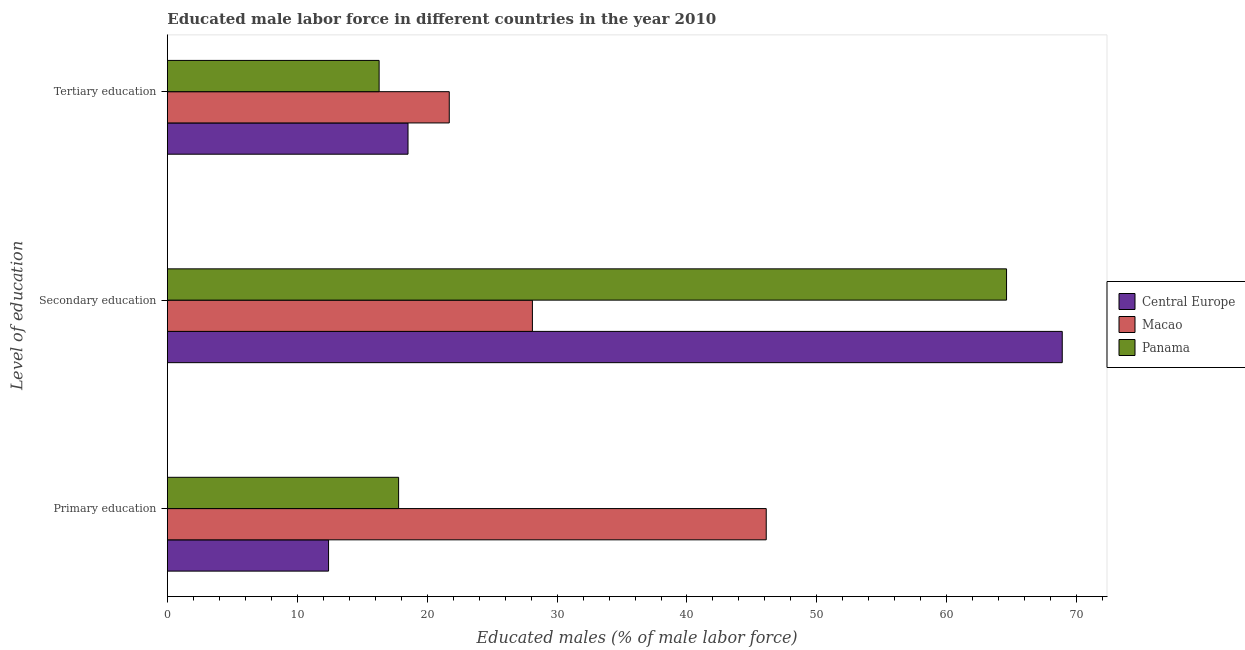Are the number of bars per tick equal to the number of legend labels?
Provide a short and direct response. Yes. What is the label of the 2nd group of bars from the top?
Make the answer very short. Secondary education. What is the percentage of male labor force who received primary education in Central Europe?
Your response must be concise. 12.41. Across all countries, what is the maximum percentage of male labor force who received tertiary education?
Keep it short and to the point. 21.7. Across all countries, what is the minimum percentage of male labor force who received secondary education?
Offer a very short reply. 28.1. In which country was the percentage of male labor force who received secondary education maximum?
Give a very brief answer. Central Europe. In which country was the percentage of male labor force who received secondary education minimum?
Your answer should be very brief. Macao. What is the total percentage of male labor force who received secondary education in the graph?
Give a very brief answer. 161.59. What is the difference between the percentage of male labor force who received primary education in Panama and that in Macao?
Provide a succinct answer. -28.3. What is the difference between the percentage of male labor force who received secondary education in Macao and the percentage of male labor force who received tertiary education in Panama?
Keep it short and to the point. 11.8. What is the average percentage of male labor force who received secondary education per country?
Provide a short and direct response. 53.86. What is the difference between the percentage of male labor force who received primary education and percentage of male labor force who received tertiary education in Macao?
Give a very brief answer. 24.4. What is the ratio of the percentage of male labor force who received secondary education in Central Europe to that in Macao?
Keep it short and to the point. 2.45. What is the difference between the highest and the second highest percentage of male labor force who received primary education?
Your answer should be compact. 28.3. What is the difference between the highest and the lowest percentage of male labor force who received tertiary education?
Provide a succinct answer. 5.4. Is the sum of the percentage of male labor force who received primary education in Panama and Central Europe greater than the maximum percentage of male labor force who received secondary education across all countries?
Ensure brevity in your answer.  No. What does the 1st bar from the top in Primary education represents?
Your response must be concise. Panama. What does the 2nd bar from the bottom in Secondary education represents?
Keep it short and to the point. Macao. Are all the bars in the graph horizontal?
Your response must be concise. Yes. What is the difference between two consecutive major ticks on the X-axis?
Keep it short and to the point. 10. Are the values on the major ticks of X-axis written in scientific E-notation?
Provide a succinct answer. No. Where does the legend appear in the graph?
Make the answer very short. Center right. How many legend labels are there?
Keep it short and to the point. 3. How are the legend labels stacked?
Your answer should be compact. Vertical. What is the title of the graph?
Make the answer very short. Educated male labor force in different countries in the year 2010. Does "Cabo Verde" appear as one of the legend labels in the graph?
Give a very brief answer. No. What is the label or title of the X-axis?
Make the answer very short. Educated males (% of male labor force). What is the label or title of the Y-axis?
Provide a short and direct response. Level of education. What is the Educated males (% of male labor force) of Central Europe in Primary education?
Your answer should be compact. 12.41. What is the Educated males (% of male labor force) of Macao in Primary education?
Your answer should be compact. 46.1. What is the Educated males (% of male labor force) of Panama in Primary education?
Your answer should be compact. 17.8. What is the Educated males (% of male labor force) in Central Europe in Secondary education?
Ensure brevity in your answer.  68.89. What is the Educated males (% of male labor force) in Macao in Secondary education?
Give a very brief answer. 28.1. What is the Educated males (% of male labor force) in Panama in Secondary education?
Your response must be concise. 64.6. What is the Educated males (% of male labor force) in Central Europe in Tertiary education?
Offer a very short reply. 18.52. What is the Educated males (% of male labor force) of Macao in Tertiary education?
Your answer should be very brief. 21.7. What is the Educated males (% of male labor force) of Panama in Tertiary education?
Your answer should be compact. 16.3. Across all Level of education, what is the maximum Educated males (% of male labor force) of Central Europe?
Your answer should be very brief. 68.89. Across all Level of education, what is the maximum Educated males (% of male labor force) of Macao?
Give a very brief answer. 46.1. Across all Level of education, what is the maximum Educated males (% of male labor force) in Panama?
Your answer should be compact. 64.6. Across all Level of education, what is the minimum Educated males (% of male labor force) of Central Europe?
Make the answer very short. 12.41. Across all Level of education, what is the minimum Educated males (% of male labor force) in Macao?
Your answer should be compact. 21.7. Across all Level of education, what is the minimum Educated males (% of male labor force) in Panama?
Your answer should be very brief. 16.3. What is the total Educated males (% of male labor force) in Central Europe in the graph?
Offer a very short reply. 99.82. What is the total Educated males (% of male labor force) of Macao in the graph?
Provide a succinct answer. 95.9. What is the total Educated males (% of male labor force) in Panama in the graph?
Your answer should be compact. 98.7. What is the difference between the Educated males (% of male labor force) in Central Europe in Primary education and that in Secondary education?
Provide a succinct answer. -56.48. What is the difference between the Educated males (% of male labor force) in Panama in Primary education and that in Secondary education?
Provide a succinct answer. -46.8. What is the difference between the Educated males (% of male labor force) of Central Europe in Primary education and that in Tertiary education?
Make the answer very short. -6.12. What is the difference between the Educated males (% of male labor force) of Macao in Primary education and that in Tertiary education?
Your answer should be very brief. 24.4. What is the difference between the Educated males (% of male labor force) of Panama in Primary education and that in Tertiary education?
Ensure brevity in your answer.  1.5. What is the difference between the Educated males (% of male labor force) of Central Europe in Secondary education and that in Tertiary education?
Provide a short and direct response. 50.36. What is the difference between the Educated males (% of male labor force) in Macao in Secondary education and that in Tertiary education?
Your answer should be very brief. 6.4. What is the difference between the Educated males (% of male labor force) in Panama in Secondary education and that in Tertiary education?
Give a very brief answer. 48.3. What is the difference between the Educated males (% of male labor force) in Central Europe in Primary education and the Educated males (% of male labor force) in Macao in Secondary education?
Offer a terse response. -15.69. What is the difference between the Educated males (% of male labor force) in Central Europe in Primary education and the Educated males (% of male labor force) in Panama in Secondary education?
Provide a succinct answer. -52.19. What is the difference between the Educated males (% of male labor force) in Macao in Primary education and the Educated males (% of male labor force) in Panama in Secondary education?
Provide a succinct answer. -18.5. What is the difference between the Educated males (% of male labor force) of Central Europe in Primary education and the Educated males (% of male labor force) of Macao in Tertiary education?
Keep it short and to the point. -9.29. What is the difference between the Educated males (% of male labor force) of Central Europe in Primary education and the Educated males (% of male labor force) of Panama in Tertiary education?
Keep it short and to the point. -3.89. What is the difference between the Educated males (% of male labor force) in Macao in Primary education and the Educated males (% of male labor force) in Panama in Tertiary education?
Offer a terse response. 29.8. What is the difference between the Educated males (% of male labor force) in Central Europe in Secondary education and the Educated males (% of male labor force) in Macao in Tertiary education?
Ensure brevity in your answer.  47.19. What is the difference between the Educated males (% of male labor force) of Central Europe in Secondary education and the Educated males (% of male labor force) of Panama in Tertiary education?
Make the answer very short. 52.59. What is the difference between the Educated males (% of male labor force) in Macao in Secondary education and the Educated males (% of male labor force) in Panama in Tertiary education?
Keep it short and to the point. 11.8. What is the average Educated males (% of male labor force) of Central Europe per Level of education?
Provide a succinct answer. 33.27. What is the average Educated males (% of male labor force) in Macao per Level of education?
Offer a very short reply. 31.97. What is the average Educated males (% of male labor force) in Panama per Level of education?
Offer a terse response. 32.9. What is the difference between the Educated males (% of male labor force) of Central Europe and Educated males (% of male labor force) of Macao in Primary education?
Offer a terse response. -33.69. What is the difference between the Educated males (% of male labor force) of Central Europe and Educated males (% of male labor force) of Panama in Primary education?
Your answer should be compact. -5.39. What is the difference between the Educated males (% of male labor force) of Macao and Educated males (% of male labor force) of Panama in Primary education?
Keep it short and to the point. 28.3. What is the difference between the Educated males (% of male labor force) in Central Europe and Educated males (% of male labor force) in Macao in Secondary education?
Keep it short and to the point. 40.79. What is the difference between the Educated males (% of male labor force) of Central Europe and Educated males (% of male labor force) of Panama in Secondary education?
Make the answer very short. 4.29. What is the difference between the Educated males (% of male labor force) in Macao and Educated males (% of male labor force) in Panama in Secondary education?
Keep it short and to the point. -36.5. What is the difference between the Educated males (% of male labor force) of Central Europe and Educated males (% of male labor force) of Macao in Tertiary education?
Your response must be concise. -3.18. What is the difference between the Educated males (% of male labor force) of Central Europe and Educated males (% of male labor force) of Panama in Tertiary education?
Offer a terse response. 2.22. What is the difference between the Educated males (% of male labor force) in Macao and Educated males (% of male labor force) in Panama in Tertiary education?
Keep it short and to the point. 5.4. What is the ratio of the Educated males (% of male labor force) of Central Europe in Primary education to that in Secondary education?
Offer a terse response. 0.18. What is the ratio of the Educated males (% of male labor force) in Macao in Primary education to that in Secondary education?
Your answer should be compact. 1.64. What is the ratio of the Educated males (% of male labor force) in Panama in Primary education to that in Secondary education?
Your answer should be very brief. 0.28. What is the ratio of the Educated males (% of male labor force) in Central Europe in Primary education to that in Tertiary education?
Provide a succinct answer. 0.67. What is the ratio of the Educated males (% of male labor force) of Macao in Primary education to that in Tertiary education?
Your answer should be compact. 2.12. What is the ratio of the Educated males (% of male labor force) in Panama in Primary education to that in Tertiary education?
Your answer should be compact. 1.09. What is the ratio of the Educated males (% of male labor force) in Central Europe in Secondary education to that in Tertiary education?
Keep it short and to the point. 3.72. What is the ratio of the Educated males (% of male labor force) in Macao in Secondary education to that in Tertiary education?
Offer a very short reply. 1.29. What is the ratio of the Educated males (% of male labor force) in Panama in Secondary education to that in Tertiary education?
Your response must be concise. 3.96. What is the difference between the highest and the second highest Educated males (% of male labor force) of Central Europe?
Give a very brief answer. 50.36. What is the difference between the highest and the second highest Educated males (% of male labor force) of Macao?
Ensure brevity in your answer.  18. What is the difference between the highest and the second highest Educated males (% of male labor force) of Panama?
Give a very brief answer. 46.8. What is the difference between the highest and the lowest Educated males (% of male labor force) of Central Europe?
Your answer should be very brief. 56.48. What is the difference between the highest and the lowest Educated males (% of male labor force) of Macao?
Your answer should be compact. 24.4. What is the difference between the highest and the lowest Educated males (% of male labor force) in Panama?
Your answer should be very brief. 48.3. 